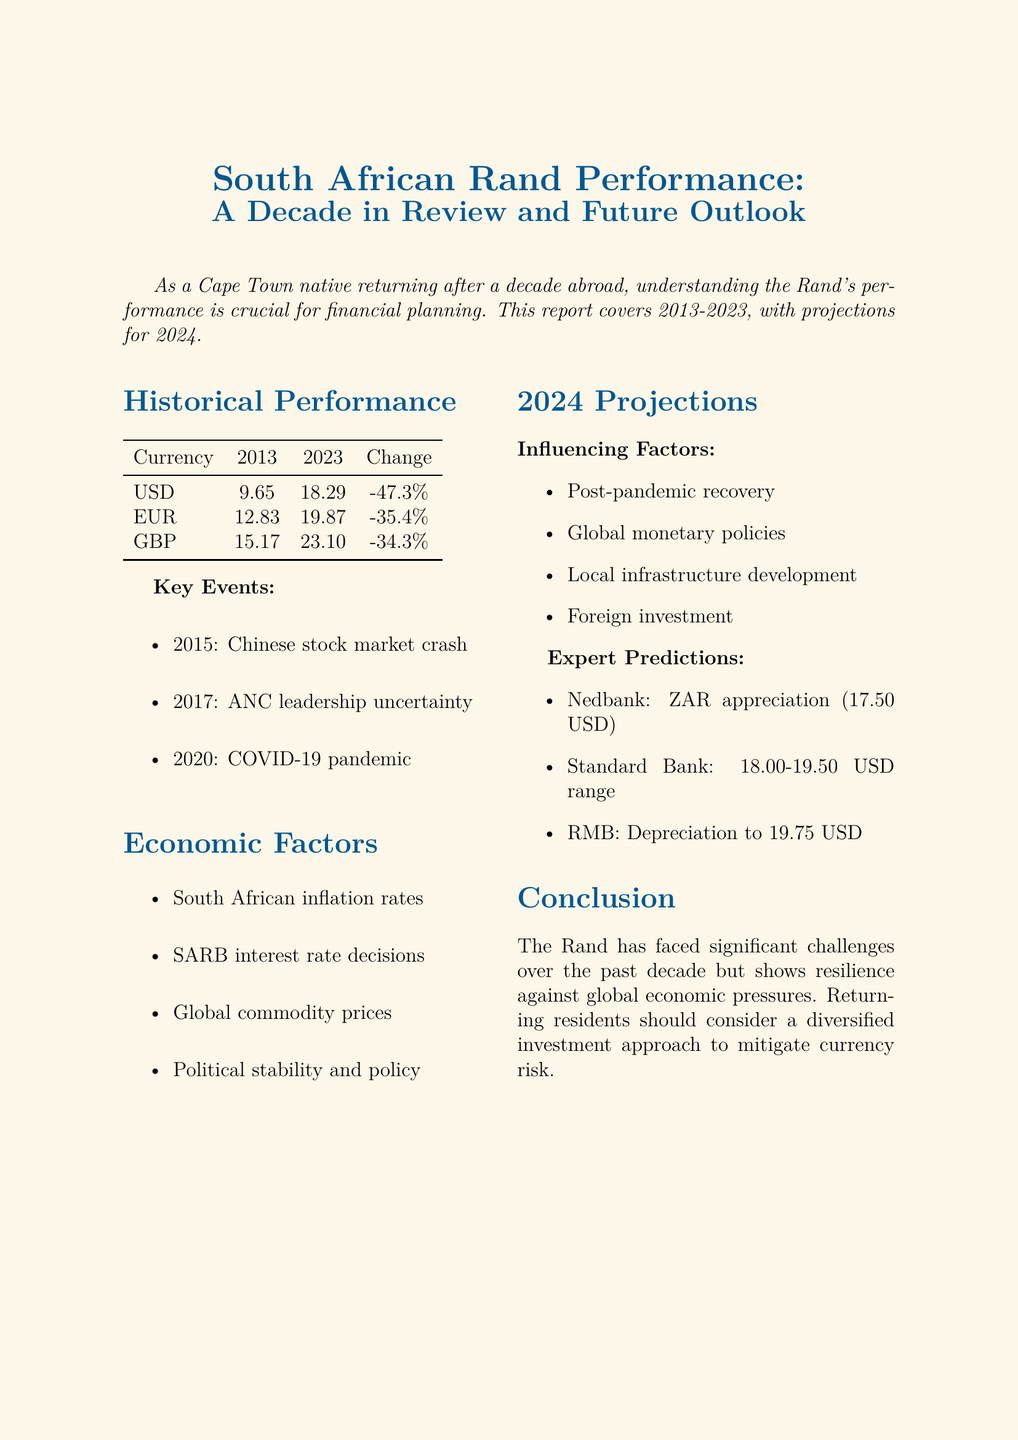what was the US Dollar rate in 2013? The document states that the US Dollar rate in 2013 was 1 USD = 9.65 ZAR.
Answer: 9.65 ZAR what is the percentage change of the Rand against the Euro from 2013 to 2023? The report indicates that the percentage change against the Euro is -35.4%.
Answer: -35.4% what key event occurred in 2020? The document lists the COVID-19 pandemic as a key event in 2020.
Answer: COVID-19 pandemic what are two economic factors influencing the Rand's performance? The document mentions South African inflation rates and global commodity prices as factors.
Answer: inflation rates, global commodity prices what is Nedbank's prediction for the USD/ZAR exchange rate by the end of 2024? Nedbank predicts a slight appreciation of the Rand, targeting 17.50 against the USD.
Answer: 17.50 which currency showed the least depreciation against the Rand from 2013 to 2023? The table indicates that the British Pound had a depreciation of -34.3%.
Answer: British Pound what does the conclusion suggest for returning residents? The conclusion advises returning residents to consider a diversified investment approach.
Answer: diversified investment approach which organization predicts a depreciation to 19.75 against USD by Q4 2024? The document notes that Rand Merchant Bank predicts this depreciation.
Answer: Rand Merchant Bank 